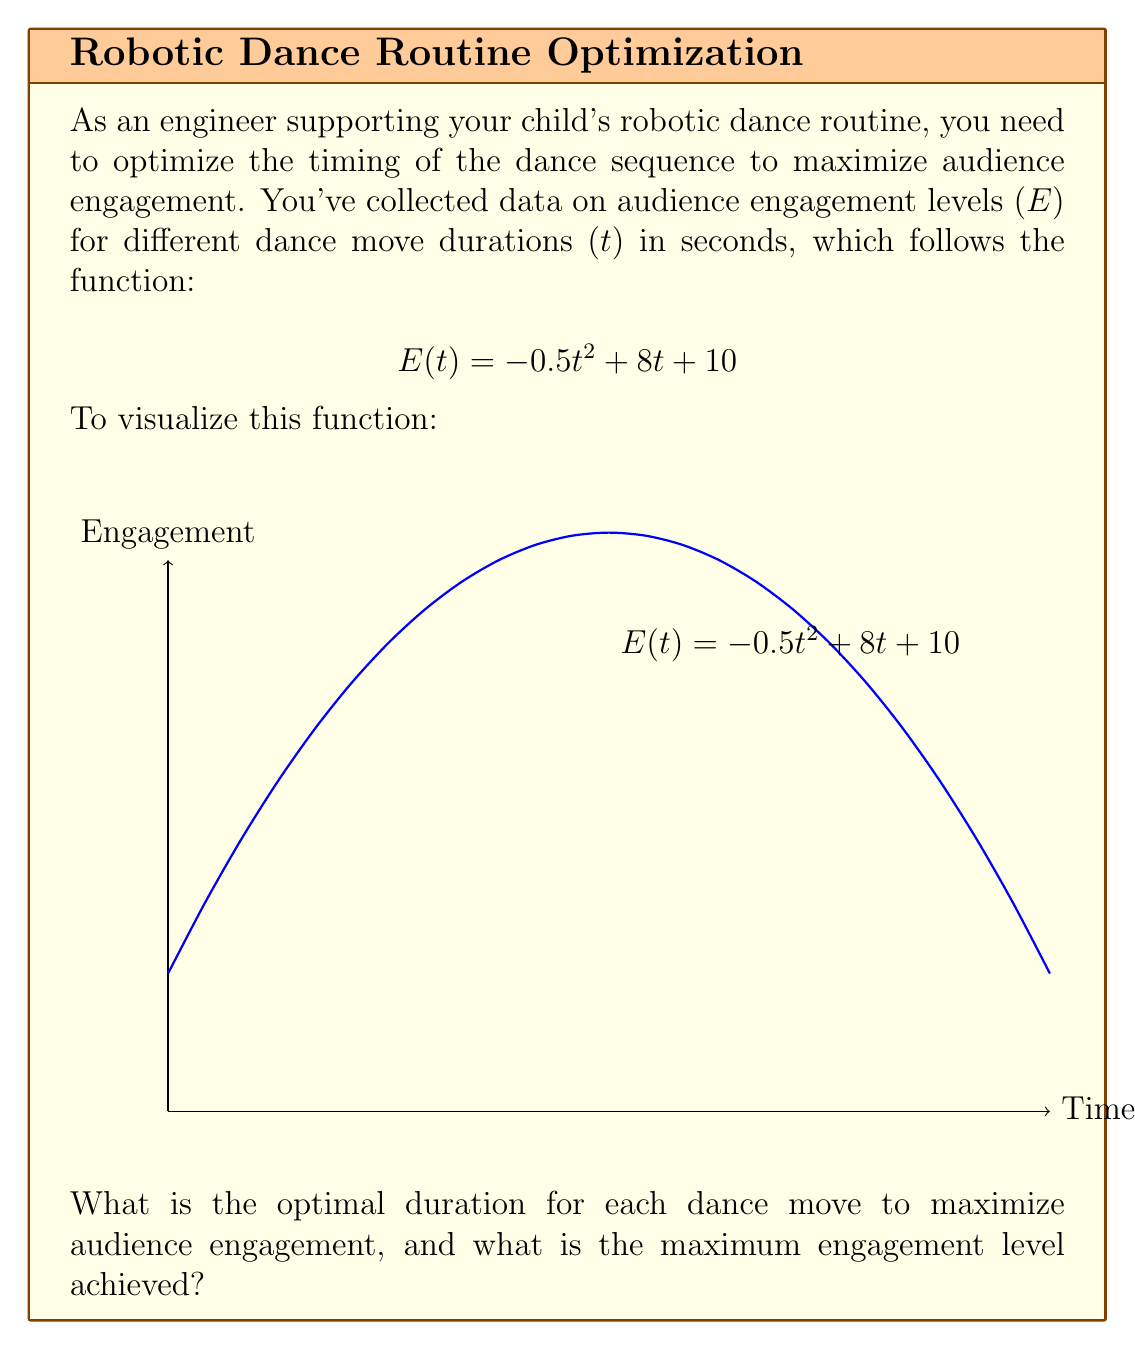Could you help me with this problem? To find the optimal duration and maximum engagement level, we need to follow these steps:

1) The engagement function is quadratic, so we can find its maximum by determining where its derivative equals zero.

2) Let's find the derivative of $E(t)$:
   $$E'(t) = -t + 8$$

3) Set the derivative to zero and solve for t:
   $$-t + 8 = 0$$
   $$t = 8$$

4) To confirm this is a maximum (not a minimum), we can check the second derivative:
   $$E''(t) = -1$$
   Since this is negative, we confirm that $t = 8$ gives a maximum.

5) Now, let's calculate the maximum engagement level by plugging $t = 8$ into our original function:
   $$E(8) = -0.5(8)^2 + 8(8) + 10$$
   $$= -0.5(64) + 64 + 10$$
   $$= -32 + 64 + 10$$
   $$= 42$$

Therefore, the optimal duration for each dance move is 8 seconds, and the maximum engagement level achieved is 42.
Answer: Optimal duration: 8 seconds; Maximum engagement: 42 